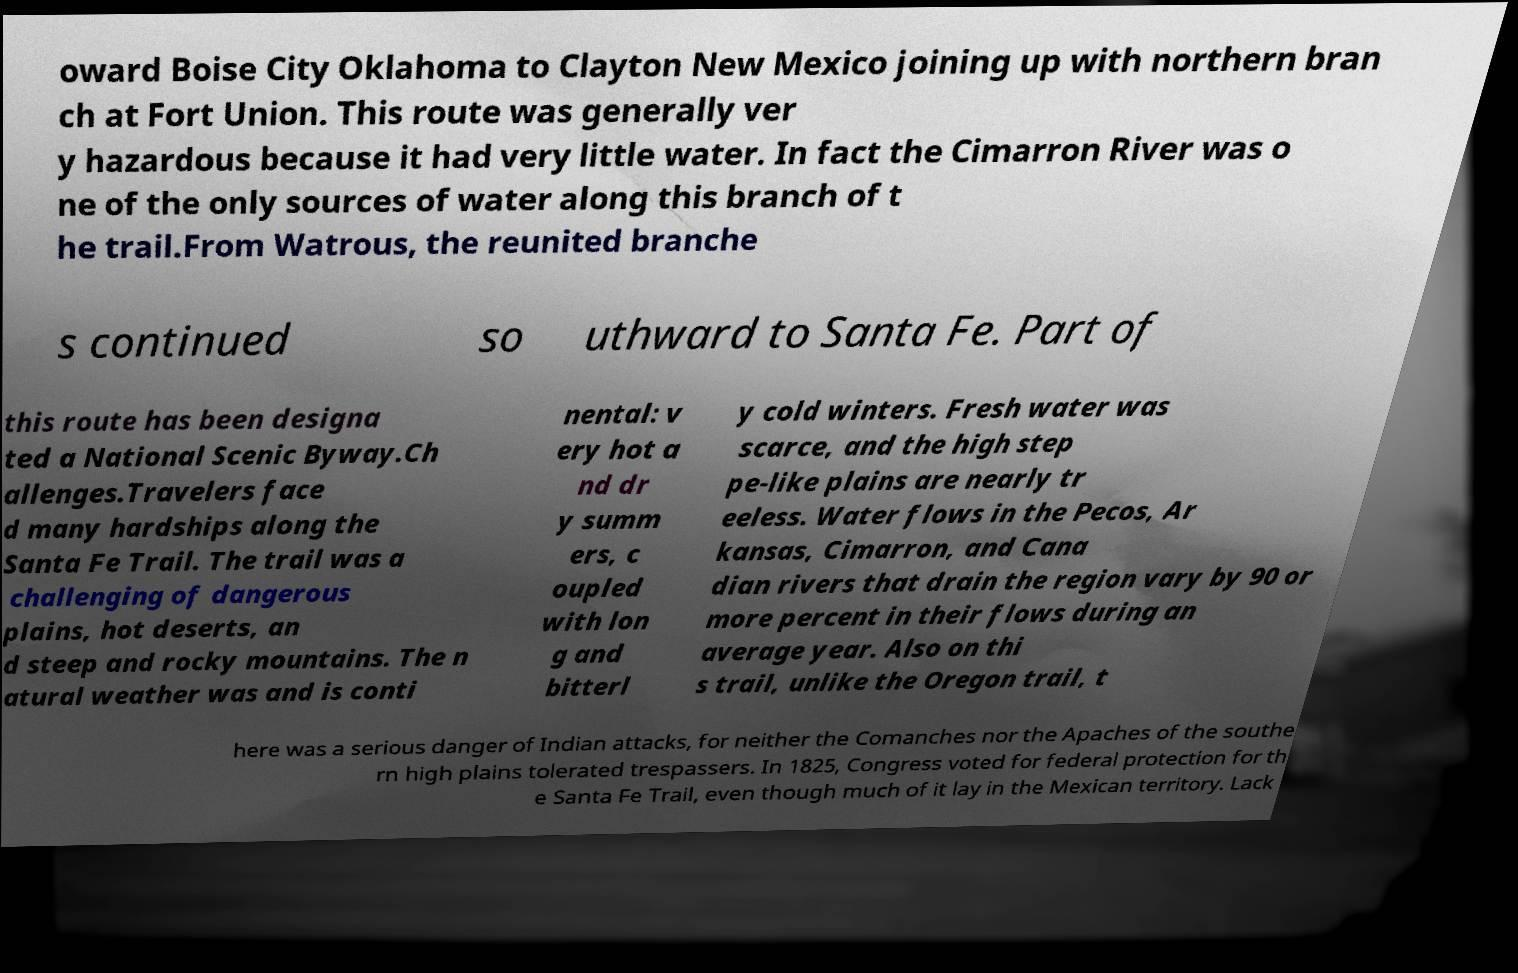Can you read and provide the text displayed in the image?This photo seems to have some interesting text. Can you extract and type it out for me? oward Boise City Oklahoma to Clayton New Mexico joining up with northern bran ch at Fort Union. This route was generally ver y hazardous because it had very little water. In fact the Cimarron River was o ne of the only sources of water along this branch of t he trail.From Watrous, the reunited branche s continued so uthward to Santa Fe. Part of this route has been designa ted a National Scenic Byway.Ch allenges.Travelers face d many hardships along the Santa Fe Trail. The trail was a challenging of dangerous plains, hot deserts, an d steep and rocky mountains. The n atural weather was and is conti nental: v ery hot a nd dr y summ ers, c oupled with lon g and bitterl y cold winters. Fresh water was scarce, and the high step pe-like plains are nearly tr eeless. Water flows in the Pecos, Ar kansas, Cimarron, and Cana dian rivers that drain the region vary by 90 or more percent in their flows during an average year. Also on thi s trail, unlike the Oregon trail, t here was a serious danger of Indian attacks, for neither the Comanches nor the Apaches of the southe rn high plains tolerated trespassers. In 1825, Congress voted for federal protection for th e Santa Fe Trail, even though much of it lay in the Mexican territory. Lack 